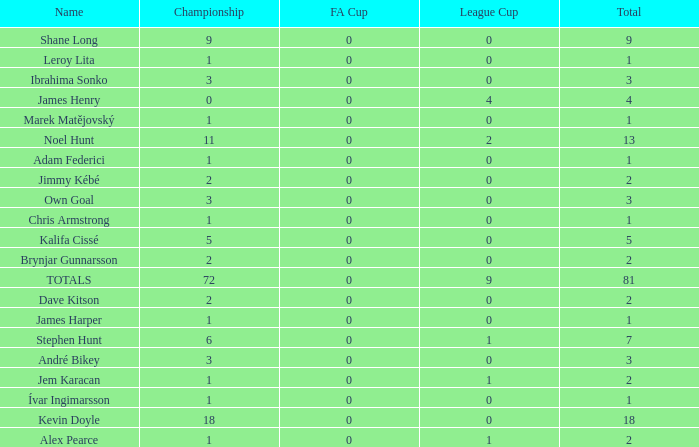What is the championship of Jem Karacan that has a total of 2 and a league cup more than 0? 1.0. 